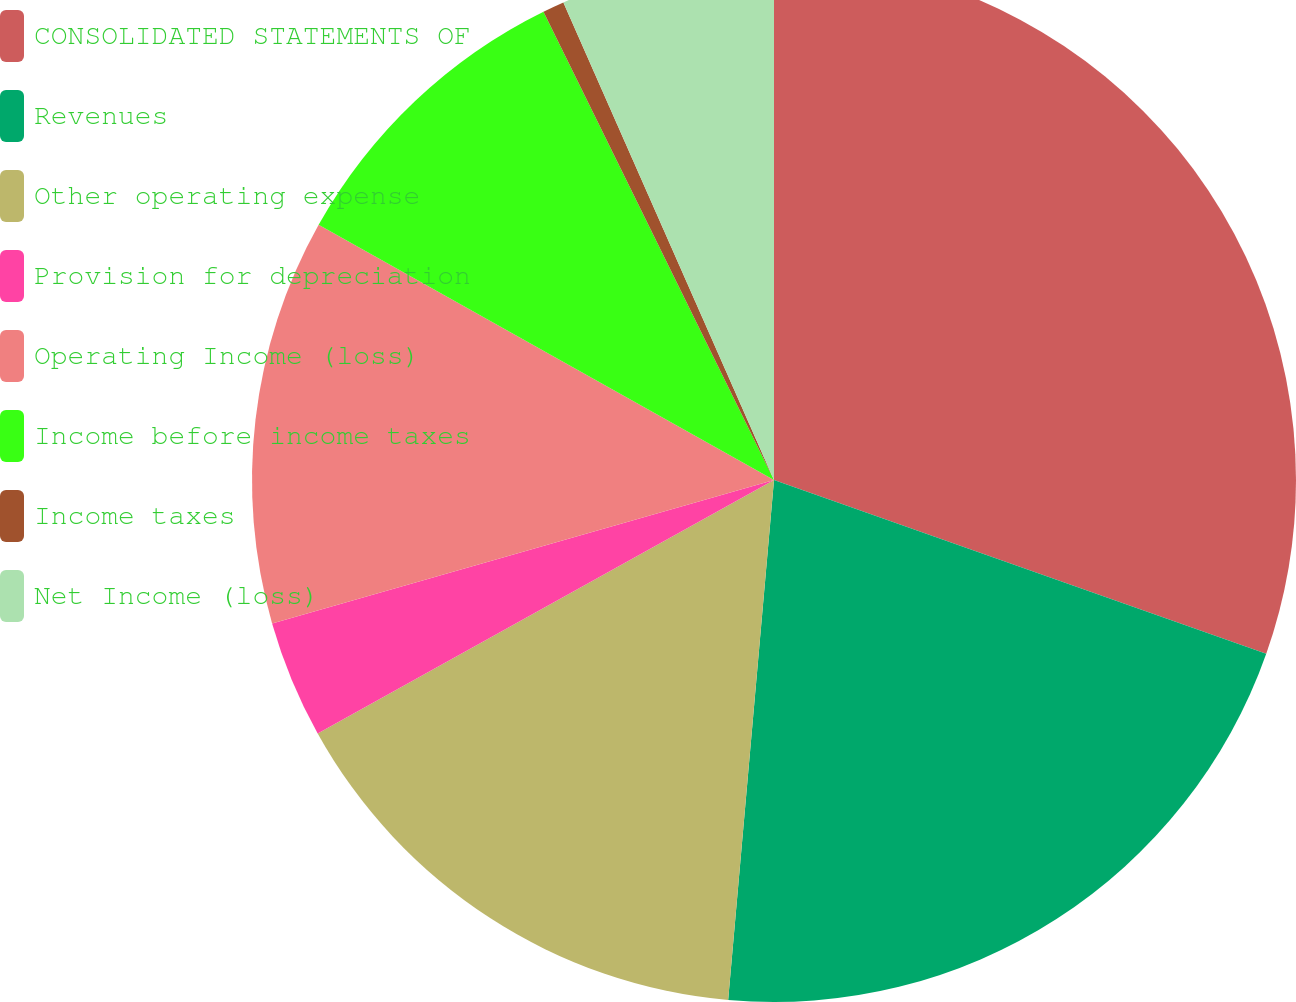<chart> <loc_0><loc_0><loc_500><loc_500><pie_chart><fcel>CONSOLIDATED STATEMENTS OF<fcel>Revenues<fcel>Other operating expense<fcel>Provision for depreciation<fcel>Operating Income (loss)<fcel>Income before income taxes<fcel>Income taxes<fcel>Net Income (loss)<nl><fcel>30.4%<fcel>21.0%<fcel>15.53%<fcel>3.64%<fcel>12.56%<fcel>9.59%<fcel>0.67%<fcel>6.61%<nl></chart> 